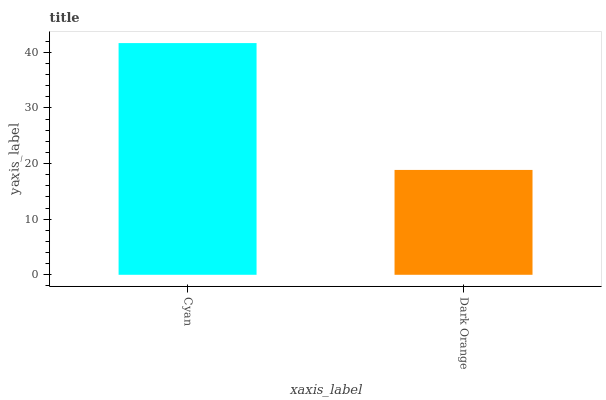Is Dark Orange the minimum?
Answer yes or no. Yes. Is Cyan the maximum?
Answer yes or no. Yes. Is Dark Orange the maximum?
Answer yes or no. No. Is Cyan greater than Dark Orange?
Answer yes or no. Yes. Is Dark Orange less than Cyan?
Answer yes or no. Yes. Is Dark Orange greater than Cyan?
Answer yes or no. No. Is Cyan less than Dark Orange?
Answer yes or no. No. Is Cyan the high median?
Answer yes or no. Yes. Is Dark Orange the low median?
Answer yes or no. Yes. Is Dark Orange the high median?
Answer yes or no. No. Is Cyan the low median?
Answer yes or no. No. 